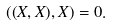Convert formula to latex. <formula><loc_0><loc_0><loc_500><loc_500>( ( X , X ) , X ) = 0 .</formula> 